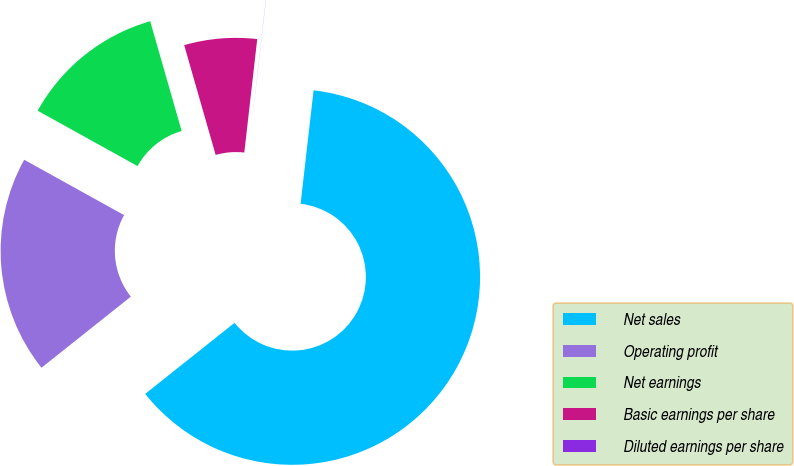<chart> <loc_0><loc_0><loc_500><loc_500><pie_chart><fcel>Net sales<fcel>Operating profit<fcel>Net earnings<fcel>Basic earnings per share<fcel>Diluted earnings per share<nl><fcel>62.49%<fcel>18.75%<fcel>12.5%<fcel>6.25%<fcel>0.01%<nl></chart> 